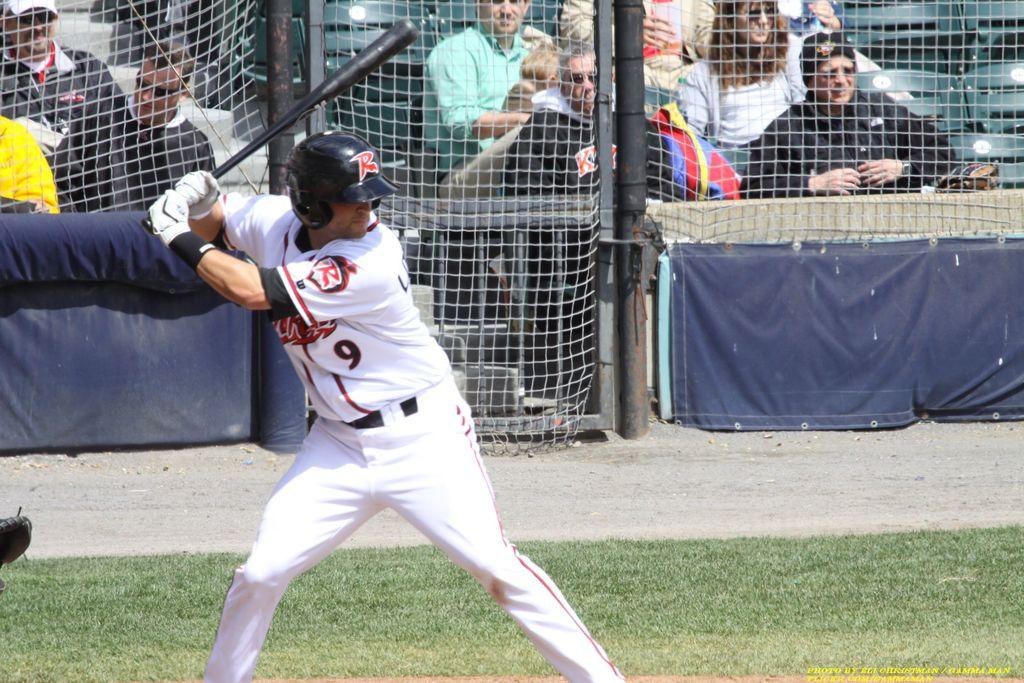Provide a one-sentence caption for the provided image. Player number 9 stands at the plate and readies for the pitch. 